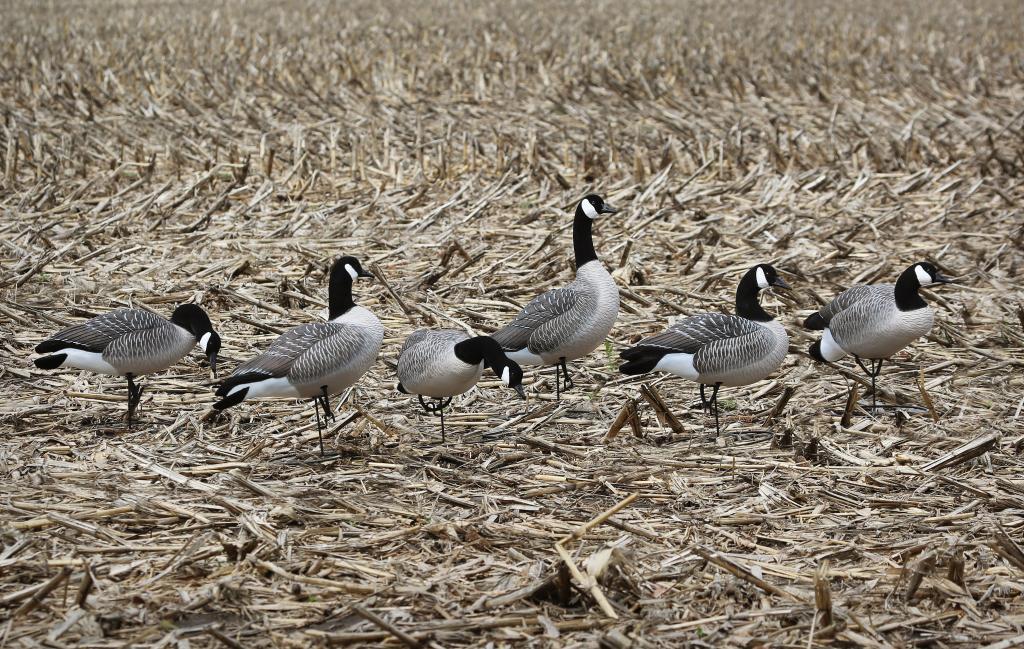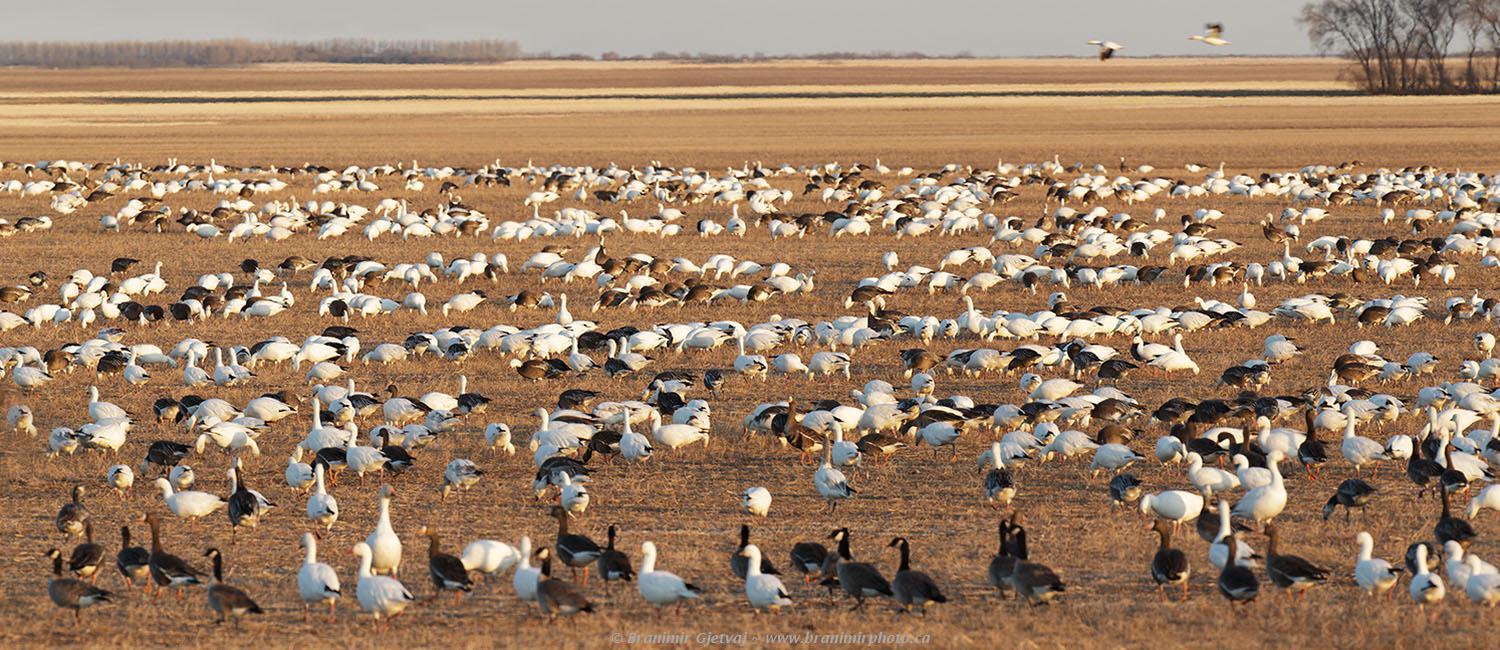The first image is the image on the left, the second image is the image on the right. For the images displayed, is the sentence "One of the images in the pair shows a flock of canada geese." factually correct? Answer yes or no. Yes. 